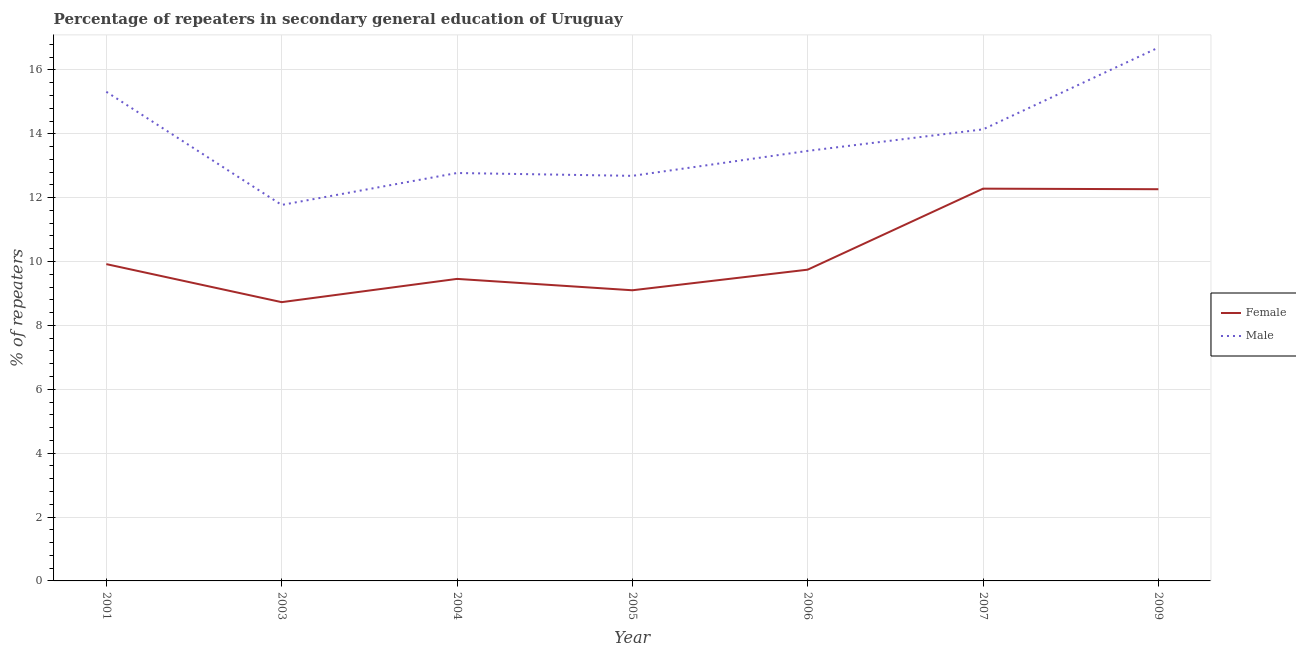Does the line corresponding to percentage of female repeaters intersect with the line corresponding to percentage of male repeaters?
Make the answer very short. No. What is the percentage of male repeaters in 2004?
Provide a succinct answer. 12.77. Across all years, what is the maximum percentage of male repeaters?
Provide a short and direct response. 16.7. Across all years, what is the minimum percentage of female repeaters?
Make the answer very short. 8.73. In which year was the percentage of male repeaters minimum?
Offer a very short reply. 2003. What is the total percentage of female repeaters in the graph?
Your answer should be very brief. 71.5. What is the difference between the percentage of female repeaters in 2003 and that in 2005?
Offer a terse response. -0.37. What is the difference between the percentage of male repeaters in 2004 and the percentage of female repeaters in 2003?
Your answer should be very brief. 4.04. What is the average percentage of male repeaters per year?
Give a very brief answer. 13.84. In the year 2007, what is the difference between the percentage of male repeaters and percentage of female repeaters?
Your answer should be compact. 1.86. What is the ratio of the percentage of male repeaters in 2005 to that in 2007?
Ensure brevity in your answer.  0.9. Is the percentage of male repeaters in 2001 less than that in 2004?
Offer a very short reply. No. Is the difference between the percentage of female repeaters in 2001 and 2004 greater than the difference between the percentage of male repeaters in 2001 and 2004?
Your response must be concise. No. What is the difference between the highest and the second highest percentage of female repeaters?
Ensure brevity in your answer.  0.02. What is the difference between the highest and the lowest percentage of male repeaters?
Your answer should be very brief. 4.93. In how many years, is the percentage of male repeaters greater than the average percentage of male repeaters taken over all years?
Offer a terse response. 3. Does the percentage of male repeaters monotonically increase over the years?
Make the answer very short. No. Is the percentage of female repeaters strictly greater than the percentage of male repeaters over the years?
Give a very brief answer. No. How many years are there in the graph?
Give a very brief answer. 7. What is the difference between two consecutive major ticks on the Y-axis?
Your response must be concise. 2. Does the graph contain grids?
Keep it short and to the point. Yes. Where does the legend appear in the graph?
Make the answer very short. Center right. How are the legend labels stacked?
Offer a terse response. Vertical. What is the title of the graph?
Your answer should be very brief. Percentage of repeaters in secondary general education of Uruguay. What is the label or title of the X-axis?
Give a very brief answer. Year. What is the label or title of the Y-axis?
Offer a very short reply. % of repeaters. What is the % of repeaters in Female in 2001?
Make the answer very short. 9.92. What is the % of repeaters in Male in 2001?
Ensure brevity in your answer.  15.32. What is the % of repeaters in Female in 2003?
Give a very brief answer. 8.73. What is the % of repeaters in Male in 2003?
Your response must be concise. 11.77. What is the % of repeaters of Female in 2004?
Provide a succinct answer. 9.46. What is the % of repeaters in Male in 2004?
Offer a terse response. 12.77. What is the % of repeaters of Female in 2005?
Your answer should be very brief. 9.1. What is the % of repeaters of Male in 2005?
Provide a short and direct response. 12.68. What is the % of repeaters of Female in 2006?
Offer a terse response. 9.75. What is the % of repeaters in Male in 2006?
Offer a terse response. 13.46. What is the % of repeaters in Female in 2007?
Provide a succinct answer. 12.28. What is the % of repeaters in Male in 2007?
Give a very brief answer. 14.14. What is the % of repeaters in Female in 2009?
Make the answer very short. 12.26. What is the % of repeaters of Male in 2009?
Offer a very short reply. 16.7. Across all years, what is the maximum % of repeaters of Female?
Give a very brief answer. 12.28. Across all years, what is the maximum % of repeaters in Male?
Offer a terse response. 16.7. Across all years, what is the minimum % of repeaters in Female?
Give a very brief answer. 8.73. Across all years, what is the minimum % of repeaters in Male?
Offer a terse response. 11.77. What is the total % of repeaters in Female in the graph?
Your answer should be compact. 71.5. What is the total % of repeaters in Male in the graph?
Ensure brevity in your answer.  96.85. What is the difference between the % of repeaters of Female in 2001 and that in 2003?
Your answer should be compact. 1.19. What is the difference between the % of repeaters in Male in 2001 and that in 2003?
Your answer should be very brief. 3.54. What is the difference between the % of repeaters of Female in 2001 and that in 2004?
Give a very brief answer. 0.46. What is the difference between the % of repeaters of Male in 2001 and that in 2004?
Offer a terse response. 2.54. What is the difference between the % of repeaters in Female in 2001 and that in 2005?
Offer a very short reply. 0.82. What is the difference between the % of repeaters of Male in 2001 and that in 2005?
Your response must be concise. 2.63. What is the difference between the % of repeaters in Female in 2001 and that in 2006?
Your response must be concise. 0.17. What is the difference between the % of repeaters in Male in 2001 and that in 2006?
Provide a succinct answer. 1.85. What is the difference between the % of repeaters in Female in 2001 and that in 2007?
Ensure brevity in your answer.  -2.36. What is the difference between the % of repeaters in Male in 2001 and that in 2007?
Ensure brevity in your answer.  1.18. What is the difference between the % of repeaters of Female in 2001 and that in 2009?
Make the answer very short. -2.35. What is the difference between the % of repeaters of Male in 2001 and that in 2009?
Your answer should be compact. -1.38. What is the difference between the % of repeaters of Female in 2003 and that in 2004?
Provide a succinct answer. -0.73. What is the difference between the % of repeaters in Male in 2003 and that in 2004?
Your response must be concise. -1. What is the difference between the % of repeaters of Female in 2003 and that in 2005?
Your response must be concise. -0.37. What is the difference between the % of repeaters of Male in 2003 and that in 2005?
Give a very brief answer. -0.91. What is the difference between the % of repeaters of Female in 2003 and that in 2006?
Ensure brevity in your answer.  -1.02. What is the difference between the % of repeaters in Male in 2003 and that in 2006?
Offer a terse response. -1.69. What is the difference between the % of repeaters in Female in 2003 and that in 2007?
Give a very brief answer. -3.55. What is the difference between the % of repeaters of Male in 2003 and that in 2007?
Provide a short and direct response. -2.37. What is the difference between the % of repeaters of Female in 2003 and that in 2009?
Make the answer very short. -3.54. What is the difference between the % of repeaters of Male in 2003 and that in 2009?
Ensure brevity in your answer.  -4.93. What is the difference between the % of repeaters of Female in 2004 and that in 2005?
Your answer should be compact. 0.36. What is the difference between the % of repeaters of Male in 2004 and that in 2005?
Provide a succinct answer. 0.09. What is the difference between the % of repeaters of Female in 2004 and that in 2006?
Keep it short and to the point. -0.29. What is the difference between the % of repeaters in Male in 2004 and that in 2006?
Keep it short and to the point. -0.69. What is the difference between the % of repeaters in Female in 2004 and that in 2007?
Ensure brevity in your answer.  -2.83. What is the difference between the % of repeaters in Male in 2004 and that in 2007?
Offer a terse response. -1.37. What is the difference between the % of repeaters in Female in 2004 and that in 2009?
Your answer should be very brief. -2.81. What is the difference between the % of repeaters of Male in 2004 and that in 2009?
Provide a short and direct response. -3.93. What is the difference between the % of repeaters in Female in 2005 and that in 2006?
Provide a succinct answer. -0.65. What is the difference between the % of repeaters in Male in 2005 and that in 2006?
Offer a very short reply. -0.78. What is the difference between the % of repeaters of Female in 2005 and that in 2007?
Give a very brief answer. -3.18. What is the difference between the % of repeaters of Male in 2005 and that in 2007?
Provide a succinct answer. -1.46. What is the difference between the % of repeaters in Female in 2005 and that in 2009?
Your answer should be very brief. -3.16. What is the difference between the % of repeaters of Male in 2005 and that in 2009?
Offer a very short reply. -4.02. What is the difference between the % of repeaters of Female in 2006 and that in 2007?
Your answer should be compact. -2.54. What is the difference between the % of repeaters of Male in 2006 and that in 2007?
Make the answer very short. -0.67. What is the difference between the % of repeaters of Female in 2006 and that in 2009?
Ensure brevity in your answer.  -2.52. What is the difference between the % of repeaters in Male in 2006 and that in 2009?
Keep it short and to the point. -3.23. What is the difference between the % of repeaters of Female in 2007 and that in 2009?
Ensure brevity in your answer.  0.02. What is the difference between the % of repeaters of Male in 2007 and that in 2009?
Give a very brief answer. -2.56. What is the difference between the % of repeaters in Female in 2001 and the % of repeaters in Male in 2003?
Your answer should be very brief. -1.85. What is the difference between the % of repeaters in Female in 2001 and the % of repeaters in Male in 2004?
Your answer should be very brief. -2.85. What is the difference between the % of repeaters in Female in 2001 and the % of repeaters in Male in 2005?
Your answer should be very brief. -2.76. What is the difference between the % of repeaters of Female in 2001 and the % of repeaters of Male in 2006?
Ensure brevity in your answer.  -3.55. What is the difference between the % of repeaters of Female in 2001 and the % of repeaters of Male in 2007?
Keep it short and to the point. -4.22. What is the difference between the % of repeaters of Female in 2001 and the % of repeaters of Male in 2009?
Offer a very short reply. -6.78. What is the difference between the % of repeaters in Female in 2003 and the % of repeaters in Male in 2004?
Offer a very short reply. -4.04. What is the difference between the % of repeaters in Female in 2003 and the % of repeaters in Male in 2005?
Keep it short and to the point. -3.95. What is the difference between the % of repeaters in Female in 2003 and the % of repeaters in Male in 2006?
Your answer should be very brief. -4.74. What is the difference between the % of repeaters of Female in 2003 and the % of repeaters of Male in 2007?
Offer a very short reply. -5.41. What is the difference between the % of repeaters in Female in 2003 and the % of repeaters in Male in 2009?
Ensure brevity in your answer.  -7.97. What is the difference between the % of repeaters in Female in 2004 and the % of repeaters in Male in 2005?
Make the answer very short. -3.23. What is the difference between the % of repeaters of Female in 2004 and the % of repeaters of Male in 2006?
Your answer should be compact. -4.01. What is the difference between the % of repeaters of Female in 2004 and the % of repeaters of Male in 2007?
Your response must be concise. -4.68. What is the difference between the % of repeaters of Female in 2004 and the % of repeaters of Male in 2009?
Your answer should be compact. -7.24. What is the difference between the % of repeaters of Female in 2005 and the % of repeaters of Male in 2006?
Provide a succinct answer. -4.36. What is the difference between the % of repeaters of Female in 2005 and the % of repeaters of Male in 2007?
Keep it short and to the point. -5.04. What is the difference between the % of repeaters of Female in 2005 and the % of repeaters of Male in 2009?
Your answer should be compact. -7.6. What is the difference between the % of repeaters in Female in 2006 and the % of repeaters in Male in 2007?
Offer a very short reply. -4.39. What is the difference between the % of repeaters of Female in 2006 and the % of repeaters of Male in 2009?
Your answer should be compact. -6.95. What is the difference between the % of repeaters of Female in 2007 and the % of repeaters of Male in 2009?
Give a very brief answer. -4.42. What is the average % of repeaters of Female per year?
Offer a very short reply. 10.21. What is the average % of repeaters of Male per year?
Offer a very short reply. 13.84. In the year 2001, what is the difference between the % of repeaters of Female and % of repeaters of Male?
Offer a terse response. -5.4. In the year 2003, what is the difference between the % of repeaters in Female and % of repeaters in Male?
Provide a succinct answer. -3.04. In the year 2004, what is the difference between the % of repeaters in Female and % of repeaters in Male?
Offer a very short reply. -3.32. In the year 2005, what is the difference between the % of repeaters in Female and % of repeaters in Male?
Offer a terse response. -3.58. In the year 2006, what is the difference between the % of repeaters of Female and % of repeaters of Male?
Make the answer very short. -3.72. In the year 2007, what is the difference between the % of repeaters of Female and % of repeaters of Male?
Offer a very short reply. -1.86. In the year 2009, what is the difference between the % of repeaters in Female and % of repeaters in Male?
Your answer should be compact. -4.43. What is the ratio of the % of repeaters of Female in 2001 to that in 2003?
Your answer should be very brief. 1.14. What is the ratio of the % of repeaters of Male in 2001 to that in 2003?
Your response must be concise. 1.3. What is the ratio of the % of repeaters of Female in 2001 to that in 2004?
Your answer should be very brief. 1.05. What is the ratio of the % of repeaters of Male in 2001 to that in 2004?
Give a very brief answer. 1.2. What is the ratio of the % of repeaters of Female in 2001 to that in 2005?
Give a very brief answer. 1.09. What is the ratio of the % of repeaters in Male in 2001 to that in 2005?
Keep it short and to the point. 1.21. What is the ratio of the % of repeaters in Female in 2001 to that in 2006?
Keep it short and to the point. 1.02. What is the ratio of the % of repeaters of Male in 2001 to that in 2006?
Provide a succinct answer. 1.14. What is the ratio of the % of repeaters in Female in 2001 to that in 2007?
Your response must be concise. 0.81. What is the ratio of the % of repeaters of Male in 2001 to that in 2007?
Ensure brevity in your answer.  1.08. What is the ratio of the % of repeaters in Female in 2001 to that in 2009?
Your answer should be very brief. 0.81. What is the ratio of the % of repeaters in Male in 2001 to that in 2009?
Ensure brevity in your answer.  0.92. What is the ratio of the % of repeaters of Female in 2003 to that in 2004?
Your answer should be compact. 0.92. What is the ratio of the % of repeaters in Male in 2003 to that in 2004?
Offer a terse response. 0.92. What is the ratio of the % of repeaters in Female in 2003 to that in 2005?
Offer a terse response. 0.96. What is the ratio of the % of repeaters of Male in 2003 to that in 2005?
Offer a very short reply. 0.93. What is the ratio of the % of repeaters in Female in 2003 to that in 2006?
Give a very brief answer. 0.9. What is the ratio of the % of repeaters in Male in 2003 to that in 2006?
Ensure brevity in your answer.  0.87. What is the ratio of the % of repeaters of Female in 2003 to that in 2007?
Your answer should be compact. 0.71. What is the ratio of the % of repeaters in Male in 2003 to that in 2007?
Make the answer very short. 0.83. What is the ratio of the % of repeaters in Female in 2003 to that in 2009?
Provide a succinct answer. 0.71. What is the ratio of the % of repeaters of Male in 2003 to that in 2009?
Your answer should be compact. 0.7. What is the ratio of the % of repeaters of Female in 2004 to that in 2005?
Your response must be concise. 1.04. What is the ratio of the % of repeaters of Male in 2004 to that in 2005?
Provide a short and direct response. 1.01. What is the ratio of the % of repeaters in Female in 2004 to that in 2006?
Provide a short and direct response. 0.97. What is the ratio of the % of repeaters in Male in 2004 to that in 2006?
Make the answer very short. 0.95. What is the ratio of the % of repeaters of Female in 2004 to that in 2007?
Make the answer very short. 0.77. What is the ratio of the % of repeaters of Male in 2004 to that in 2007?
Keep it short and to the point. 0.9. What is the ratio of the % of repeaters in Female in 2004 to that in 2009?
Provide a short and direct response. 0.77. What is the ratio of the % of repeaters of Male in 2004 to that in 2009?
Ensure brevity in your answer.  0.76. What is the ratio of the % of repeaters of Female in 2005 to that in 2006?
Make the answer very short. 0.93. What is the ratio of the % of repeaters of Male in 2005 to that in 2006?
Provide a short and direct response. 0.94. What is the ratio of the % of repeaters in Female in 2005 to that in 2007?
Offer a terse response. 0.74. What is the ratio of the % of repeaters of Male in 2005 to that in 2007?
Your response must be concise. 0.9. What is the ratio of the % of repeaters of Female in 2005 to that in 2009?
Offer a very short reply. 0.74. What is the ratio of the % of repeaters of Male in 2005 to that in 2009?
Your answer should be compact. 0.76. What is the ratio of the % of repeaters of Female in 2006 to that in 2007?
Your response must be concise. 0.79. What is the ratio of the % of repeaters in Male in 2006 to that in 2007?
Offer a very short reply. 0.95. What is the ratio of the % of repeaters in Female in 2006 to that in 2009?
Provide a short and direct response. 0.79. What is the ratio of the % of repeaters in Male in 2006 to that in 2009?
Your response must be concise. 0.81. What is the ratio of the % of repeaters of Male in 2007 to that in 2009?
Offer a terse response. 0.85. What is the difference between the highest and the second highest % of repeaters of Female?
Give a very brief answer. 0.02. What is the difference between the highest and the second highest % of repeaters of Male?
Keep it short and to the point. 1.38. What is the difference between the highest and the lowest % of repeaters in Female?
Your response must be concise. 3.55. What is the difference between the highest and the lowest % of repeaters of Male?
Keep it short and to the point. 4.93. 